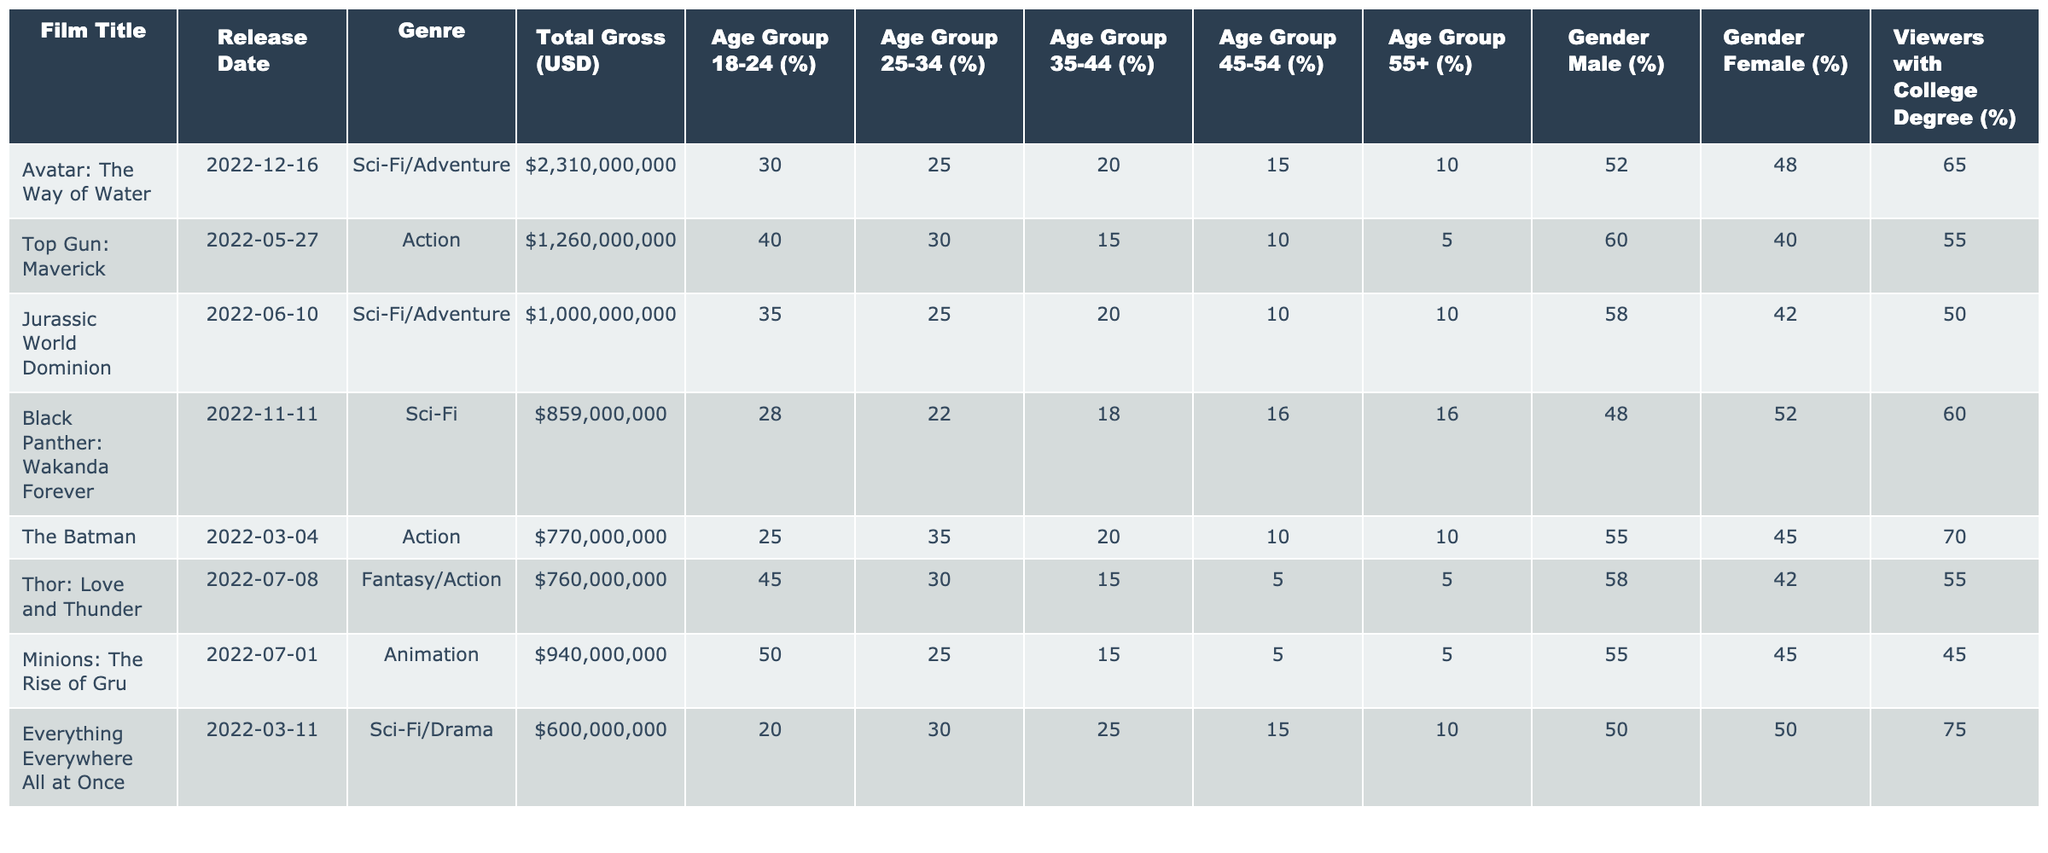What is the total gross earnings for "Avatar: The Way of Water"? The total gross earnings for this film, as listed in the table, is $2,310,000,000.
Answer: $2,310,000,000 Which film has the highest percentage of viewers aged 18-24? By comparing the percentages of viewers aged 18-24 across all films, "Minions: The Rise of Gru" has the highest at 50%.
Answer: 50% How much total gross do the top three films earn combined? The total gross earnings are calculated as follows: Avatar: $2,310,000,000 + Top Gun: $1,260,000,000 + Jurassic World: $1,000,000,000 = $4,570,000,000.
Answer: $4,570,000,000 Is it true that "Top Gun: Maverick" has a higher percentage of male viewers compared to "Black Panther: Wakanda Forever"? "Top Gun: Maverick" has 60% male viewers, while "Black Panther: Wakanda Forever" has 48%. Therefore, it is true that Top Gun has a higher percentage of male viewers.
Answer: Yes What is the average percentage of the viewers with a college degree for all films listed? The sum of the percentages of viewers with a college degree is (65 + 55 + 50 + 60 + 70 + 55 + 45 + 75) = 495. There are 8 films, so the average is 495 / 8 = 61.875, which rounds to approximately 62%.
Answer: 62% Which genre has the lowest average percentage of viewers aged 45-54? First, we calculate the average for each genre: "Sci-Fi/Adventure" = (15 + 10) / 2 = 12.5, "Action" = (10 + 10) / 2 = 10, "Animation" = 5, "Fantasy/Action" = 5, "Drama" = 15. The lowest average percentage is 5% for "Animation" and "Fantasy/Action."
Answer: Animation and Fantasy/Action For films where the majority of viewers are male, what percentage of those viewers have a college degree? The male-majority films are "Top Gun: Maverick," "Jurassic World Dominion," "The Batman," "Thor: Love and Thunder," and "Minions." Their college degree percentages are 55, 50, 70, 55, and 45 respectively. The average of these five is (55 + 50 + 70 + 55 + 45) / 5 = 55%.
Answer: 55% Which film has the oldest audience (highest percentage in the 55+ age group)? The percentages for the 55+ age group are: Avatar: 10%, Top Gun: 5%, Jurassic World: 10%, Black Panther: 16%, The Batman: 10%, Thor: 5%, Minions: 5%, Everything Everywhere: 10%. The highest percentage is for "Black Panther: Wakanda Forever" with 16%.
Answer: Black Panther: Wakanda Forever 